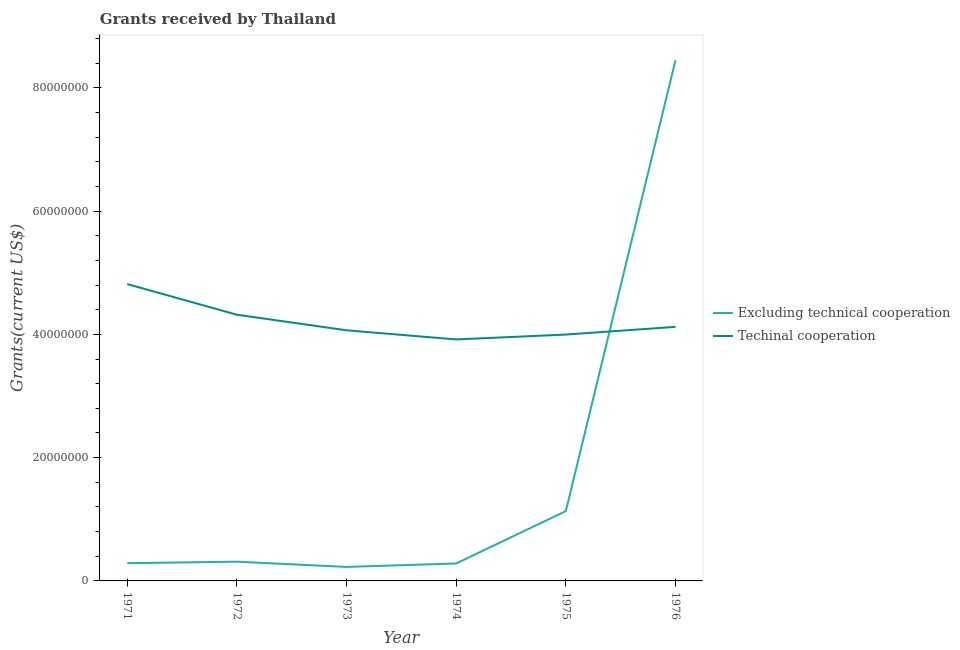What is the amount of grants received(excluding technical cooperation) in 1974?
Your response must be concise. 2.83e+06. Across all years, what is the maximum amount of grants received(excluding technical cooperation)?
Provide a short and direct response. 8.45e+07. Across all years, what is the minimum amount of grants received(including technical cooperation)?
Your answer should be very brief. 3.92e+07. In which year was the amount of grants received(including technical cooperation) maximum?
Your response must be concise. 1971. In which year was the amount of grants received(excluding technical cooperation) minimum?
Your response must be concise. 1973. What is the total amount of grants received(excluding technical cooperation) in the graph?
Ensure brevity in your answer.  1.07e+08. What is the difference between the amount of grants received(including technical cooperation) in 1972 and that in 1974?
Offer a very short reply. 4.01e+06. What is the difference between the amount of grants received(excluding technical cooperation) in 1972 and the amount of grants received(including technical cooperation) in 1973?
Keep it short and to the point. -3.75e+07. What is the average amount of grants received(excluding technical cooperation) per year?
Provide a short and direct response. 1.78e+07. In the year 1976, what is the difference between the amount of grants received(excluding technical cooperation) and amount of grants received(including technical cooperation)?
Ensure brevity in your answer.  4.33e+07. What is the ratio of the amount of grants received(including technical cooperation) in 1971 to that in 1975?
Offer a very short reply. 1.2. What is the difference between the highest and the second highest amount of grants received(including technical cooperation)?
Keep it short and to the point. 4.97e+06. What is the difference between the highest and the lowest amount of grants received(including technical cooperation)?
Your response must be concise. 8.98e+06. In how many years, is the amount of grants received(including technical cooperation) greater than the average amount of grants received(including technical cooperation) taken over all years?
Your response must be concise. 2. Is the amount of grants received(including technical cooperation) strictly less than the amount of grants received(excluding technical cooperation) over the years?
Offer a very short reply. No. How many lines are there?
Ensure brevity in your answer.  2. Are the values on the major ticks of Y-axis written in scientific E-notation?
Make the answer very short. No. Does the graph contain any zero values?
Give a very brief answer. No. Does the graph contain grids?
Your response must be concise. No. Where does the legend appear in the graph?
Offer a very short reply. Center right. What is the title of the graph?
Your response must be concise. Grants received by Thailand. What is the label or title of the X-axis?
Provide a short and direct response. Year. What is the label or title of the Y-axis?
Give a very brief answer. Grants(current US$). What is the Grants(current US$) of Excluding technical cooperation in 1971?
Ensure brevity in your answer.  2.88e+06. What is the Grants(current US$) in Techinal cooperation in 1971?
Give a very brief answer. 4.82e+07. What is the Grants(current US$) in Excluding technical cooperation in 1972?
Offer a terse response. 3.12e+06. What is the Grants(current US$) in Techinal cooperation in 1972?
Offer a terse response. 4.32e+07. What is the Grants(current US$) of Excluding technical cooperation in 1973?
Your answer should be very brief. 2.27e+06. What is the Grants(current US$) in Techinal cooperation in 1973?
Your answer should be compact. 4.07e+07. What is the Grants(current US$) of Excluding technical cooperation in 1974?
Give a very brief answer. 2.83e+06. What is the Grants(current US$) in Techinal cooperation in 1974?
Keep it short and to the point. 3.92e+07. What is the Grants(current US$) of Excluding technical cooperation in 1975?
Your response must be concise. 1.13e+07. What is the Grants(current US$) of Techinal cooperation in 1975?
Your answer should be compact. 4.00e+07. What is the Grants(current US$) in Excluding technical cooperation in 1976?
Give a very brief answer. 8.45e+07. What is the Grants(current US$) in Techinal cooperation in 1976?
Offer a very short reply. 4.12e+07. Across all years, what is the maximum Grants(current US$) in Excluding technical cooperation?
Make the answer very short. 8.45e+07. Across all years, what is the maximum Grants(current US$) in Techinal cooperation?
Offer a very short reply. 4.82e+07. Across all years, what is the minimum Grants(current US$) in Excluding technical cooperation?
Offer a terse response. 2.27e+06. Across all years, what is the minimum Grants(current US$) of Techinal cooperation?
Your answer should be compact. 3.92e+07. What is the total Grants(current US$) of Excluding technical cooperation in the graph?
Ensure brevity in your answer.  1.07e+08. What is the total Grants(current US$) of Techinal cooperation in the graph?
Ensure brevity in your answer.  2.52e+08. What is the difference between the Grants(current US$) in Excluding technical cooperation in 1971 and that in 1972?
Your answer should be very brief. -2.40e+05. What is the difference between the Grants(current US$) of Techinal cooperation in 1971 and that in 1972?
Ensure brevity in your answer.  4.97e+06. What is the difference between the Grants(current US$) in Techinal cooperation in 1971 and that in 1973?
Your answer should be compact. 7.50e+06. What is the difference between the Grants(current US$) of Techinal cooperation in 1971 and that in 1974?
Offer a very short reply. 8.98e+06. What is the difference between the Grants(current US$) of Excluding technical cooperation in 1971 and that in 1975?
Keep it short and to the point. -8.45e+06. What is the difference between the Grants(current US$) in Techinal cooperation in 1971 and that in 1975?
Your answer should be very brief. 8.19e+06. What is the difference between the Grants(current US$) in Excluding technical cooperation in 1971 and that in 1976?
Your answer should be very brief. -8.16e+07. What is the difference between the Grants(current US$) of Techinal cooperation in 1971 and that in 1976?
Your answer should be very brief. 6.94e+06. What is the difference between the Grants(current US$) of Excluding technical cooperation in 1972 and that in 1973?
Your answer should be compact. 8.50e+05. What is the difference between the Grants(current US$) of Techinal cooperation in 1972 and that in 1973?
Your answer should be very brief. 2.53e+06. What is the difference between the Grants(current US$) in Excluding technical cooperation in 1972 and that in 1974?
Offer a terse response. 2.90e+05. What is the difference between the Grants(current US$) in Techinal cooperation in 1972 and that in 1974?
Your answer should be very brief. 4.01e+06. What is the difference between the Grants(current US$) in Excluding technical cooperation in 1972 and that in 1975?
Ensure brevity in your answer.  -8.21e+06. What is the difference between the Grants(current US$) of Techinal cooperation in 1972 and that in 1975?
Make the answer very short. 3.22e+06. What is the difference between the Grants(current US$) in Excluding technical cooperation in 1972 and that in 1976?
Ensure brevity in your answer.  -8.14e+07. What is the difference between the Grants(current US$) in Techinal cooperation in 1972 and that in 1976?
Your answer should be very brief. 1.97e+06. What is the difference between the Grants(current US$) in Excluding technical cooperation in 1973 and that in 1974?
Provide a short and direct response. -5.60e+05. What is the difference between the Grants(current US$) in Techinal cooperation in 1973 and that in 1974?
Keep it short and to the point. 1.48e+06. What is the difference between the Grants(current US$) in Excluding technical cooperation in 1973 and that in 1975?
Provide a short and direct response. -9.06e+06. What is the difference between the Grants(current US$) of Techinal cooperation in 1973 and that in 1975?
Give a very brief answer. 6.90e+05. What is the difference between the Grants(current US$) in Excluding technical cooperation in 1973 and that in 1976?
Your answer should be compact. -8.22e+07. What is the difference between the Grants(current US$) in Techinal cooperation in 1973 and that in 1976?
Ensure brevity in your answer.  -5.60e+05. What is the difference between the Grants(current US$) of Excluding technical cooperation in 1974 and that in 1975?
Keep it short and to the point. -8.50e+06. What is the difference between the Grants(current US$) in Techinal cooperation in 1974 and that in 1975?
Your response must be concise. -7.90e+05. What is the difference between the Grants(current US$) in Excluding technical cooperation in 1974 and that in 1976?
Make the answer very short. -8.16e+07. What is the difference between the Grants(current US$) in Techinal cooperation in 1974 and that in 1976?
Keep it short and to the point. -2.04e+06. What is the difference between the Grants(current US$) of Excluding technical cooperation in 1975 and that in 1976?
Ensure brevity in your answer.  -7.32e+07. What is the difference between the Grants(current US$) in Techinal cooperation in 1975 and that in 1976?
Make the answer very short. -1.25e+06. What is the difference between the Grants(current US$) of Excluding technical cooperation in 1971 and the Grants(current US$) of Techinal cooperation in 1972?
Offer a terse response. -4.03e+07. What is the difference between the Grants(current US$) in Excluding technical cooperation in 1971 and the Grants(current US$) in Techinal cooperation in 1973?
Offer a very short reply. -3.78e+07. What is the difference between the Grants(current US$) of Excluding technical cooperation in 1971 and the Grants(current US$) of Techinal cooperation in 1974?
Your answer should be very brief. -3.63e+07. What is the difference between the Grants(current US$) in Excluding technical cooperation in 1971 and the Grants(current US$) in Techinal cooperation in 1975?
Give a very brief answer. -3.71e+07. What is the difference between the Grants(current US$) of Excluding technical cooperation in 1971 and the Grants(current US$) of Techinal cooperation in 1976?
Make the answer very short. -3.83e+07. What is the difference between the Grants(current US$) in Excluding technical cooperation in 1972 and the Grants(current US$) in Techinal cooperation in 1973?
Give a very brief answer. -3.75e+07. What is the difference between the Grants(current US$) of Excluding technical cooperation in 1972 and the Grants(current US$) of Techinal cooperation in 1974?
Your answer should be very brief. -3.61e+07. What is the difference between the Grants(current US$) in Excluding technical cooperation in 1972 and the Grants(current US$) in Techinal cooperation in 1975?
Keep it short and to the point. -3.68e+07. What is the difference between the Grants(current US$) in Excluding technical cooperation in 1972 and the Grants(current US$) in Techinal cooperation in 1976?
Offer a very short reply. -3.81e+07. What is the difference between the Grants(current US$) in Excluding technical cooperation in 1973 and the Grants(current US$) in Techinal cooperation in 1974?
Offer a terse response. -3.69e+07. What is the difference between the Grants(current US$) of Excluding technical cooperation in 1973 and the Grants(current US$) of Techinal cooperation in 1975?
Your answer should be very brief. -3.77e+07. What is the difference between the Grants(current US$) in Excluding technical cooperation in 1973 and the Grants(current US$) in Techinal cooperation in 1976?
Keep it short and to the point. -3.90e+07. What is the difference between the Grants(current US$) of Excluding technical cooperation in 1974 and the Grants(current US$) of Techinal cooperation in 1975?
Keep it short and to the point. -3.71e+07. What is the difference between the Grants(current US$) of Excluding technical cooperation in 1974 and the Grants(current US$) of Techinal cooperation in 1976?
Give a very brief answer. -3.84e+07. What is the difference between the Grants(current US$) in Excluding technical cooperation in 1975 and the Grants(current US$) in Techinal cooperation in 1976?
Keep it short and to the point. -2.99e+07. What is the average Grants(current US$) of Excluding technical cooperation per year?
Provide a short and direct response. 1.78e+07. What is the average Grants(current US$) of Techinal cooperation per year?
Your response must be concise. 4.21e+07. In the year 1971, what is the difference between the Grants(current US$) of Excluding technical cooperation and Grants(current US$) of Techinal cooperation?
Offer a terse response. -4.53e+07. In the year 1972, what is the difference between the Grants(current US$) in Excluding technical cooperation and Grants(current US$) in Techinal cooperation?
Offer a very short reply. -4.01e+07. In the year 1973, what is the difference between the Grants(current US$) in Excluding technical cooperation and Grants(current US$) in Techinal cooperation?
Offer a terse response. -3.84e+07. In the year 1974, what is the difference between the Grants(current US$) in Excluding technical cooperation and Grants(current US$) in Techinal cooperation?
Your answer should be very brief. -3.64e+07. In the year 1975, what is the difference between the Grants(current US$) of Excluding technical cooperation and Grants(current US$) of Techinal cooperation?
Make the answer very short. -2.86e+07. In the year 1976, what is the difference between the Grants(current US$) in Excluding technical cooperation and Grants(current US$) in Techinal cooperation?
Provide a short and direct response. 4.33e+07. What is the ratio of the Grants(current US$) of Excluding technical cooperation in 1971 to that in 1972?
Offer a terse response. 0.92. What is the ratio of the Grants(current US$) of Techinal cooperation in 1971 to that in 1972?
Offer a terse response. 1.12. What is the ratio of the Grants(current US$) of Excluding technical cooperation in 1971 to that in 1973?
Offer a very short reply. 1.27. What is the ratio of the Grants(current US$) of Techinal cooperation in 1971 to that in 1973?
Ensure brevity in your answer.  1.18. What is the ratio of the Grants(current US$) in Excluding technical cooperation in 1971 to that in 1974?
Offer a terse response. 1.02. What is the ratio of the Grants(current US$) of Techinal cooperation in 1971 to that in 1974?
Offer a very short reply. 1.23. What is the ratio of the Grants(current US$) of Excluding technical cooperation in 1971 to that in 1975?
Keep it short and to the point. 0.25. What is the ratio of the Grants(current US$) of Techinal cooperation in 1971 to that in 1975?
Keep it short and to the point. 1.2. What is the ratio of the Grants(current US$) of Excluding technical cooperation in 1971 to that in 1976?
Your response must be concise. 0.03. What is the ratio of the Grants(current US$) of Techinal cooperation in 1971 to that in 1976?
Make the answer very short. 1.17. What is the ratio of the Grants(current US$) in Excluding technical cooperation in 1972 to that in 1973?
Keep it short and to the point. 1.37. What is the ratio of the Grants(current US$) of Techinal cooperation in 1972 to that in 1973?
Your answer should be very brief. 1.06. What is the ratio of the Grants(current US$) in Excluding technical cooperation in 1972 to that in 1974?
Your answer should be very brief. 1.1. What is the ratio of the Grants(current US$) in Techinal cooperation in 1972 to that in 1974?
Your answer should be very brief. 1.1. What is the ratio of the Grants(current US$) of Excluding technical cooperation in 1972 to that in 1975?
Provide a succinct answer. 0.28. What is the ratio of the Grants(current US$) of Techinal cooperation in 1972 to that in 1975?
Your answer should be compact. 1.08. What is the ratio of the Grants(current US$) in Excluding technical cooperation in 1972 to that in 1976?
Ensure brevity in your answer.  0.04. What is the ratio of the Grants(current US$) in Techinal cooperation in 1972 to that in 1976?
Give a very brief answer. 1.05. What is the ratio of the Grants(current US$) of Excluding technical cooperation in 1973 to that in 1974?
Keep it short and to the point. 0.8. What is the ratio of the Grants(current US$) in Techinal cooperation in 1973 to that in 1974?
Your answer should be compact. 1.04. What is the ratio of the Grants(current US$) of Excluding technical cooperation in 1973 to that in 1975?
Provide a succinct answer. 0.2. What is the ratio of the Grants(current US$) of Techinal cooperation in 1973 to that in 1975?
Make the answer very short. 1.02. What is the ratio of the Grants(current US$) of Excluding technical cooperation in 1973 to that in 1976?
Your response must be concise. 0.03. What is the ratio of the Grants(current US$) in Techinal cooperation in 1973 to that in 1976?
Ensure brevity in your answer.  0.99. What is the ratio of the Grants(current US$) of Excluding technical cooperation in 1974 to that in 1975?
Ensure brevity in your answer.  0.25. What is the ratio of the Grants(current US$) of Techinal cooperation in 1974 to that in 1975?
Keep it short and to the point. 0.98. What is the ratio of the Grants(current US$) of Excluding technical cooperation in 1974 to that in 1976?
Your response must be concise. 0.03. What is the ratio of the Grants(current US$) of Techinal cooperation in 1974 to that in 1976?
Provide a succinct answer. 0.95. What is the ratio of the Grants(current US$) in Excluding technical cooperation in 1975 to that in 1976?
Your answer should be very brief. 0.13. What is the ratio of the Grants(current US$) in Techinal cooperation in 1975 to that in 1976?
Offer a terse response. 0.97. What is the difference between the highest and the second highest Grants(current US$) in Excluding technical cooperation?
Your answer should be very brief. 7.32e+07. What is the difference between the highest and the second highest Grants(current US$) in Techinal cooperation?
Give a very brief answer. 4.97e+06. What is the difference between the highest and the lowest Grants(current US$) in Excluding technical cooperation?
Your response must be concise. 8.22e+07. What is the difference between the highest and the lowest Grants(current US$) in Techinal cooperation?
Your answer should be compact. 8.98e+06. 